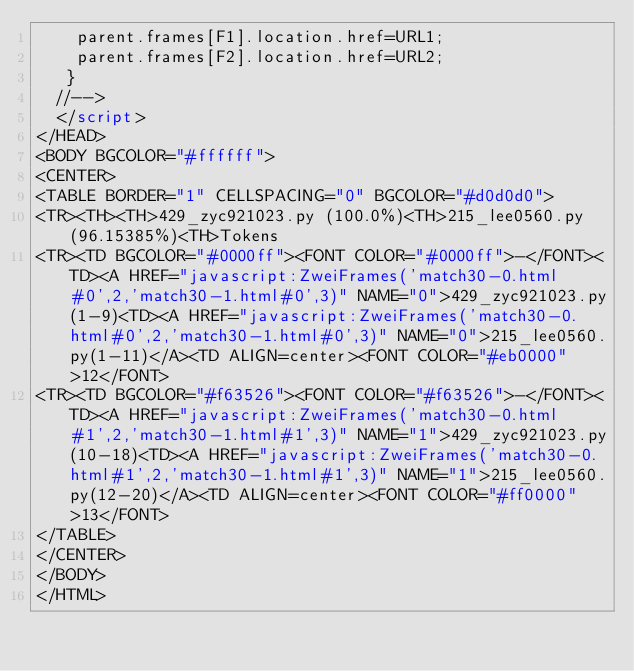<code> <loc_0><loc_0><loc_500><loc_500><_HTML_>    parent.frames[F1].location.href=URL1;
    parent.frames[F2].location.href=URL2;
   }
  //-->
  </script>
</HEAD>
<BODY BGCOLOR="#ffffff">
<CENTER>
<TABLE BORDER="1" CELLSPACING="0" BGCOLOR="#d0d0d0">
<TR><TH><TH>429_zyc921023.py (100.0%)<TH>215_lee0560.py (96.15385%)<TH>Tokens
<TR><TD BGCOLOR="#0000ff"><FONT COLOR="#0000ff">-</FONT><TD><A HREF="javascript:ZweiFrames('match30-0.html#0',2,'match30-1.html#0',3)" NAME="0">429_zyc921023.py(1-9)<TD><A HREF="javascript:ZweiFrames('match30-0.html#0',2,'match30-1.html#0',3)" NAME="0">215_lee0560.py(1-11)</A><TD ALIGN=center><FONT COLOR="#eb0000">12</FONT>
<TR><TD BGCOLOR="#f63526"><FONT COLOR="#f63526">-</FONT><TD><A HREF="javascript:ZweiFrames('match30-0.html#1',2,'match30-1.html#1',3)" NAME="1">429_zyc921023.py(10-18)<TD><A HREF="javascript:ZweiFrames('match30-0.html#1',2,'match30-1.html#1',3)" NAME="1">215_lee0560.py(12-20)</A><TD ALIGN=center><FONT COLOR="#ff0000">13</FONT>
</TABLE>
</CENTER>
</BODY>
</HTML>

</code> 